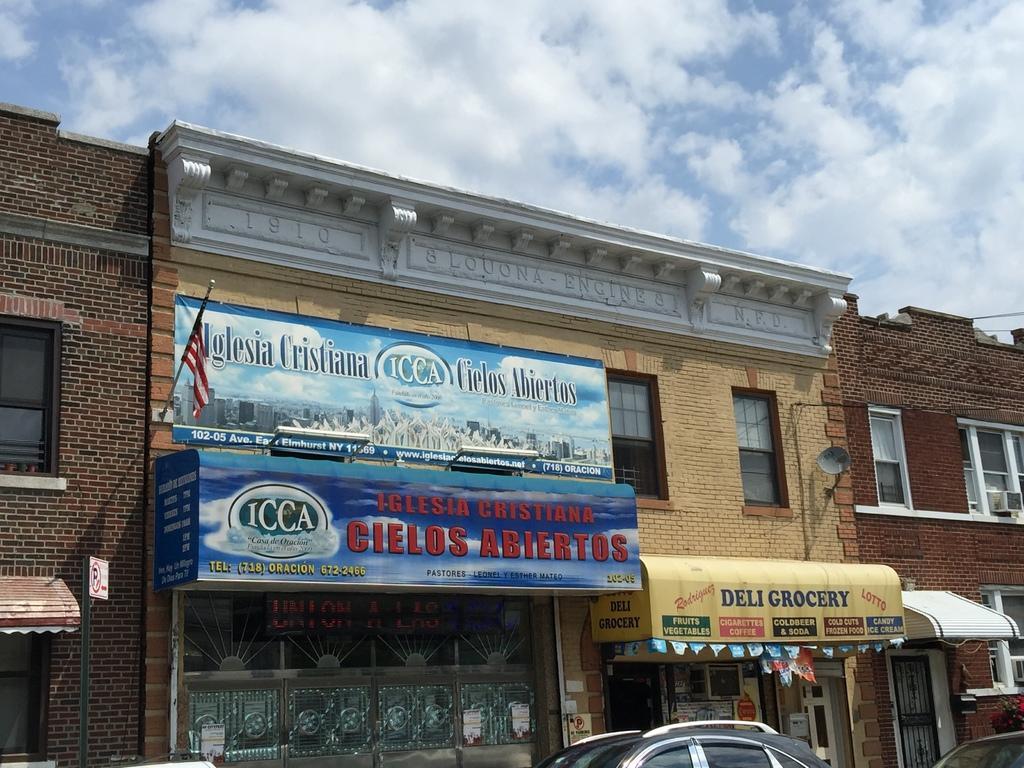Could you give a brief overview of what you see in this image? In this image, we can see a building. There is a car at the bottom of the image. There is a flag on the wall. There are clouds in the sky. 